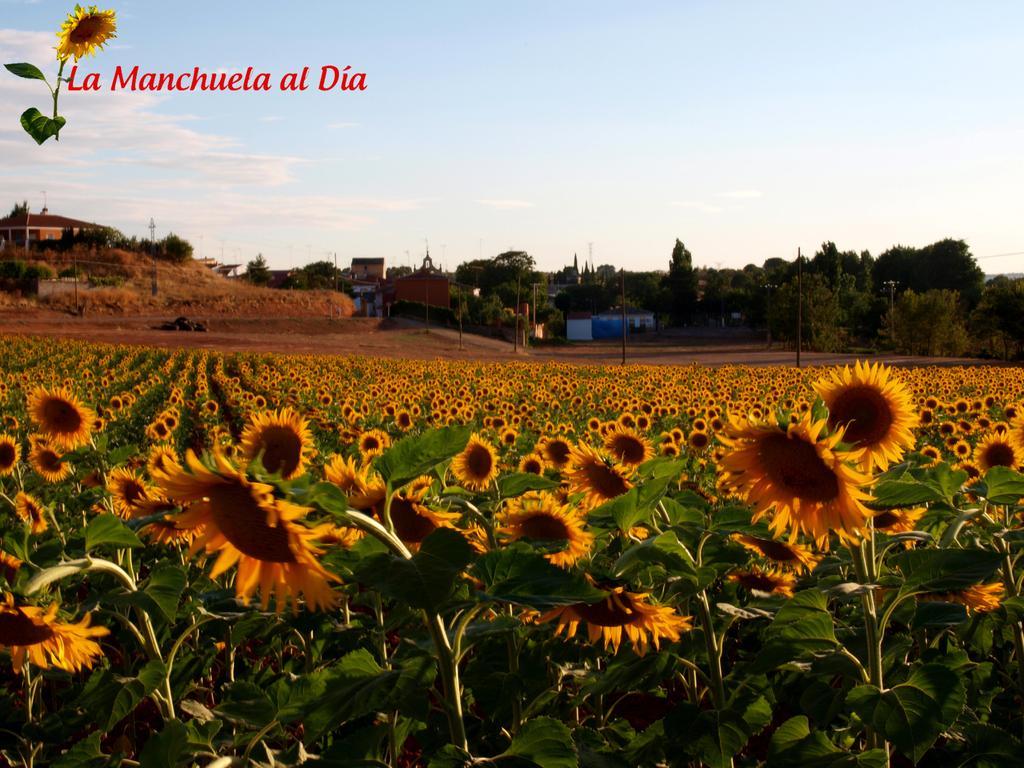In one or two sentences, can you explain what this image depicts? On the top left, there is a watermark. Below this, there are plants having sunflowers and green color leaves. In the background, there is a dry land, there is a hill, there are trees, there are buildings and there are clouds in the blue sky. 